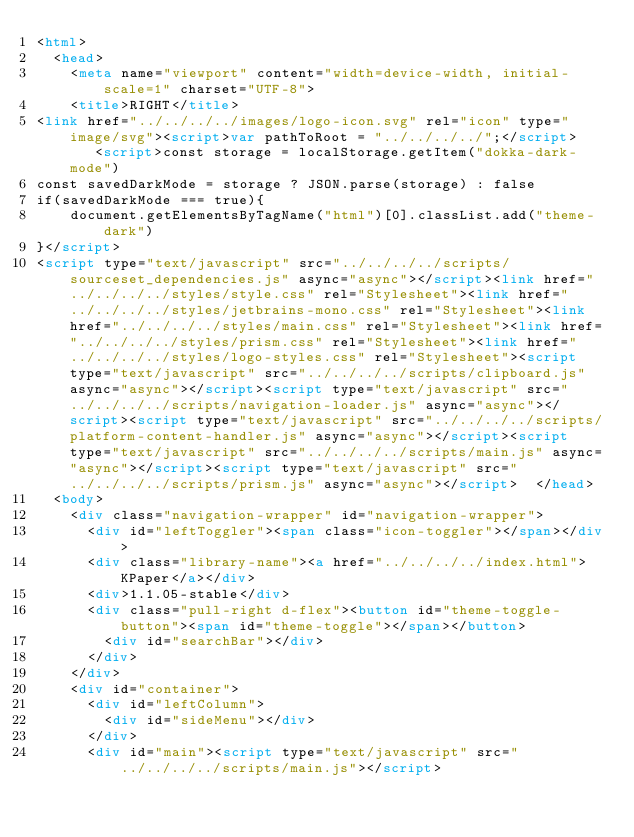Convert code to text. <code><loc_0><loc_0><loc_500><loc_500><_HTML_><html>
  <head>
    <meta name="viewport" content="width=device-width, initial-scale=1" charset="UTF-8">
    <title>RIGHT</title>
<link href="../../../../images/logo-icon.svg" rel="icon" type="image/svg"><script>var pathToRoot = "../../../../";</script>    <script>const storage = localStorage.getItem("dokka-dark-mode")
const savedDarkMode = storage ? JSON.parse(storage) : false
if(savedDarkMode === true){
    document.getElementsByTagName("html")[0].classList.add("theme-dark")
}</script>
<script type="text/javascript" src="../../../../scripts/sourceset_dependencies.js" async="async"></script><link href="../../../../styles/style.css" rel="Stylesheet"><link href="../../../../styles/jetbrains-mono.css" rel="Stylesheet"><link href="../../../../styles/main.css" rel="Stylesheet"><link href="../../../../styles/prism.css" rel="Stylesheet"><link href="../../../../styles/logo-styles.css" rel="Stylesheet"><script type="text/javascript" src="../../../../scripts/clipboard.js" async="async"></script><script type="text/javascript" src="../../../../scripts/navigation-loader.js" async="async"></script><script type="text/javascript" src="../../../../scripts/platform-content-handler.js" async="async"></script><script type="text/javascript" src="../../../../scripts/main.js" async="async"></script><script type="text/javascript" src="../../../../scripts/prism.js" async="async"></script>  </head>
  <body>
    <div class="navigation-wrapper" id="navigation-wrapper">
      <div id="leftToggler"><span class="icon-toggler"></span></div>
      <div class="library-name"><a href="../../../../index.html">KPaper</a></div>
      <div>1.1.05-stable</div>
      <div class="pull-right d-flex"><button id="theme-toggle-button"><span id="theme-toggle"></span></button>
        <div id="searchBar"></div>
      </div>
    </div>
    <div id="container">
      <div id="leftColumn">
        <div id="sideMenu"></div>
      </div>
      <div id="main"><script type="text/javascript" src="../../../../scripts/main.js"></script></code> 